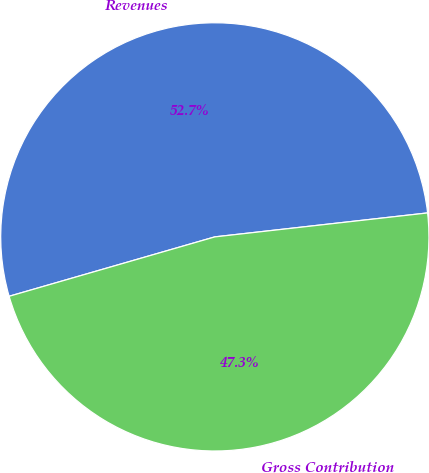Convert chart. <chart><loc_0><loc_0><loc_500><loc_500><pie_chart><fcel>Revenues<fcel>Gross Contribution<nl><fcel>52.69%<fcel>47.31%<nl></chart> 